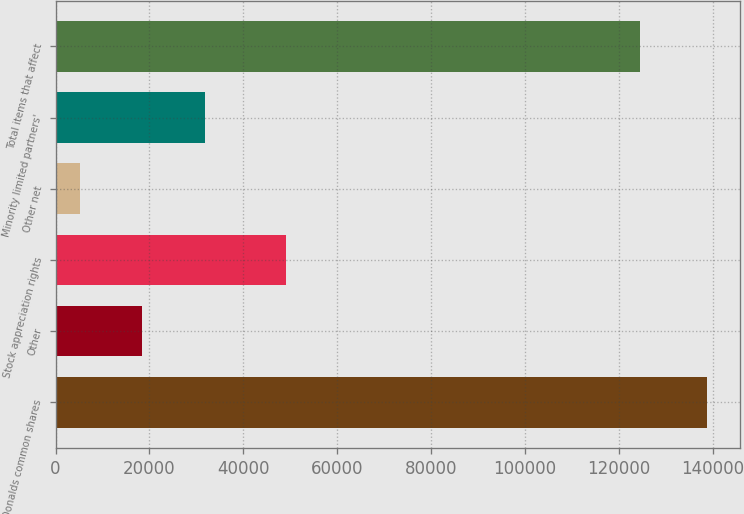Convert chart. <chart><loc_0><loc_0><loc_500><loc_500><bar_chart><fcel>McDonalds common shares<fcel>Other<fcel>Stock appreciation rights<fcel>Other net<fcel>Minority limited partners'<fcel>Total items that affect<nl><fcel>138815<fcel>18494.9<fcel>49043<fcel>5126<fcel>31863.8<fcel>124630<nl></chart> 